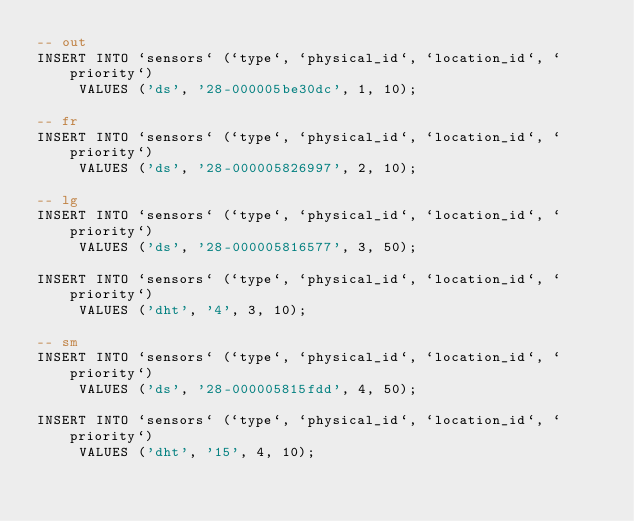Convert code to text. <code><loc_0><loc_0><loc_500><loc_500><_SQL_>-- out
INSERT INTO `sensors` (`type`, `physical_id`, `location_id`, `priority`)
     VALUES ('ds', '28-000005be30dc', 1, 10);

-- fr
INSERT INTO `sensors` (`type`, `physical_id`, `location_id`, `priority`)
     VALUES ('ds', '28-000005826997', 2, 10);

-- lg
INSERT INTO `sensors` (`type`, `physical_id`, `location_id`, `priority`)
     VALUES ('ds', '28-000005816577', 3, 50);

INSERT INTO `sensors` (`type`, `physical_id`, `location_id`, `priority`)
     VALUES ('dht', '4', 3, 10);

-- sm
INSERT INTO `sensors` (`type`, `physical_id`, `location_id`, `priority`)
     VALUES ('ds', '28-000005815fdd', 4, 50);

INSERT INTO `sensors` (`type`, `physical_id`, `location_id`, `priority`)
     VALUES ('dht', '15', 4, 10);



</code> 